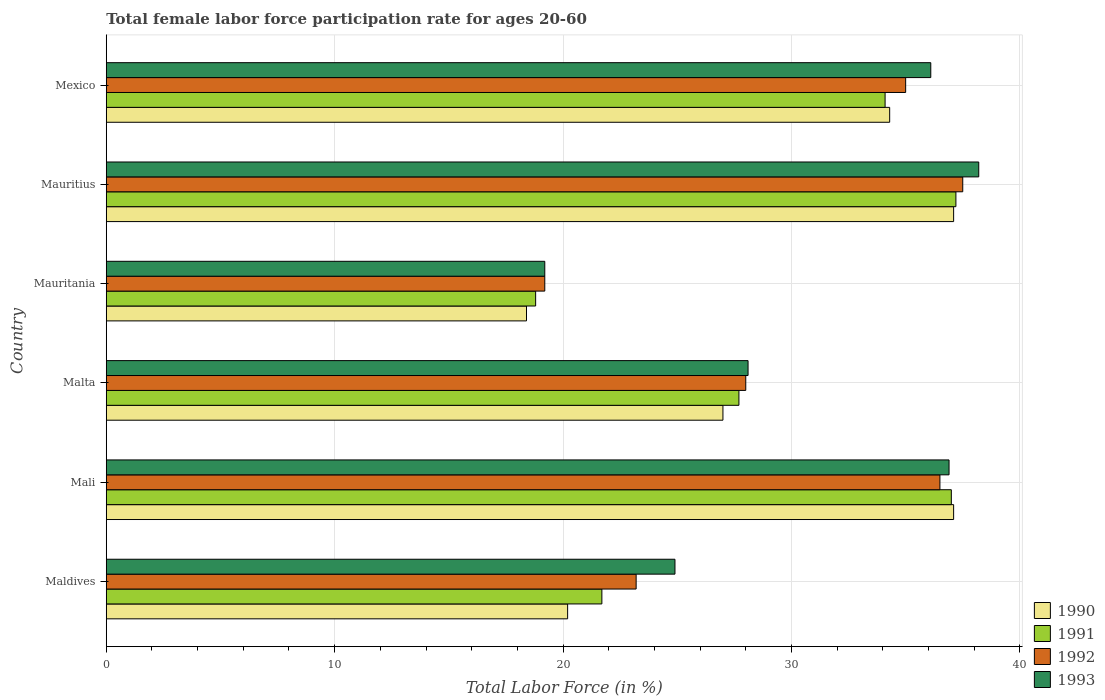How many bars are there on the 5th tick from the top?
Ensure brevity in your answer.  4. How many bars are there on the 1st tick from the bottom?
Make the answer very short. 4. What is the label of the 2nd group of bars from the top?
Provide a succinct answer. Mauritius. In how many cases, is the number of bars for a given country not equal to the number of legend labels?
Your answer should be compact. 0. What is the female labor force participation rate in 1990 in Mali?
Keep it short and to the point. 37.1. Across all countries, what is the maximum female labor force participation rate in 1991?
Ensure brevity in your answer.  37.2. Across all countries, what is the minimum female labor force participation rate in 1990?
Offer a terse response. 18.4. In which country was the female labor force participation rate in 1991 maximum?
Your answer should be very brief. Mauritius. In which country was the female labor force participation rate in 1991 minimum?
Your response must be concise. Mauritania. What is the total female labor force participation rate in 1992 in the graph?
Provide a succinct answer. 179.4. What is the difference between the female labor force participation rate in 1993 in Maldives and that in Mauritius?
Make the answer very short. -13.3. What is the difference between the female labor force participation rate in 1992 in Maldives and the female labor force participation rate in 1993 in Mauritius?
Make the answer very short. -15. What is the average female labor force participation rate in 1992 per country?
Your response must be concise. 29.9. In how many countries, is the female labor force participation rate in 1991 greater than 12 %?
Give a very brief answer. 6. What is the ratio of the female labor force participation rate in 1990 in Mali to that in Mauritania?
Your answer should be very brief. 2.02. Is the female labor force participation rate in 1992 in Maldives less than that in Malta?
Make the answer very short. Yes. Is the difference between the female labor force participation rate in 1991 in Mauritania and Mauritius greater than the difference between the female labor force participation rate in 1993 in Mauritania and Mauritius?
Give a very brief answer. Yes. What is the difference between the highest and the lowest female labor force participation rate in 1990?
Your response must be concise. 18.7. Is the sum of the female labor force participation rate in 1991 in Mauritania and Mexico greater than the maximum female labor force participation rate in 1993 across all countries?
Provide a succinct answer. Yes. Is it the case that in every country, the sum of the female labor force participation rate in 1993 and female labor force participation rate in 1991 is greater than the female labor force participation rate in 1992?
Provide a succinct answer. Yes. Are all the bars in the graph horizontal?
Keep it short and to the point. Yes. How many countries are there in the graph?
Offer a terse response. 6. What is the difference between two consecutive major ticks on the X-axis?
Provide a short and direct response. 10. How many legend labels are there?
Your answer should be compact. 4. What is the title of the graph?
Provide a short and direct response. Total female labor force participation rate for ages 20-60. What is the Total Labor Force (in %) of 1990 in Maldives?
Your answer should be compact. 20.2. What is the Total Labor Force (in %) in 1991 in Maldives?
Ensure brevity in your answer.  21.7. What is the Total Labor Force (in %) of 1992 in Maldives?
Your answer should be compact. 23.2. What is the Total Labor Force (in %) in 1993 in Maldives?
Make the answer very short. 24.9. What is the Total Labor Force (in %) in 1990 in Mali?
Your response must be concise. 37.1. What is the Total Labor Force (in %) in 1991 in Mali?
Keep it short and to the point. 37. What is the Total Labor Force (in %) of 1992 in Mali?
Provide a succinct answer. 36.5. What is the Total Labor Force (in %) of 1993 in Mali?
Your answer should be very brief. 36.9. What is the Total Labor Force (in %) in 1991 in Malta?
Make the answer very short. 27.7. What is the Total Labor Force (in %) of 1993 in Malta?
Your answer should be compact. 28.1. What is the Total Labor Force (in %) of 1990 in Mauritania?
Your answer should be compact. 18.4. What is the Total Labor Force (in %) in 1991 in Mauritania?
Ensure brevity in your answer.  18.8. What is the Total Labor Force (in %) of 1992 in Mauritania?
Your answer should be very brief. 19.2. What is the Total Labor Force (in %) in 1993 in Mauritania?
Provide a succinct answer. 19.2. What is the Total Labor Force (in %) in 1990 in Mauritius?
Keep it short and to the point. 37.1. What is the Total Labor Force (in %) of 1991 in Mauritius?
Provide a succinct answer. 37.2. What is the Total Labor Force (in %) in 1992 in Mauritius?
Your response must be concise. 37.5. What is the Total Labor Force (in %) in 1993 in Mauritius?
Keep it short and to the point. 38.2. What is the Total Labor Force (in %) of 1990 in Mexico?
Provide a succinct answer. 34.3. What is the Total Labor Force (in %) of 1991 in Mexico?
Provide a succinct answer. 34.1. What is the Total Labor Force (in %) in 1992 in Mexico?
Provide a succinct answer. 35. What is the Total Labor Force (in %) in 1993 in Mexico?
Ensure brevity in your answer.  36.1. Across all countries, what is the maximum Total Labor Force (in %) of 1990?
Make the answer very short. 37.1. Across all countries, what is the maximum Total Labor Force (in %) of 1991?
Offer a very short reply. 37.2. Across all countries, what is the maximum Total Labor Force (in %) of 1992?
Give a very brief answer. 37.5. Across all countries, what is the maximum Total Labor Force (in %) in 1993?
Ensure brevity in your answer.  38.2. Across all countries, what is the minimum Total Labor Force (in %) of 1990?
Offer a terse response. 18.4. Across all countries, what is the minimum Total Labor Force (in %) in 1991?
Give a very brief answer. 18.8. Across all countries, what is the minimum Total Labor Force (in %) of 1992?
Offer a very short reply. 19.2. Across all countries, what is the minimum Total Labor Force (in %) of 1993?
Provide a succinct answer. 19.2. What is the total Total Labor Force (in %) in 1990 in the graph?
Offer a very short reply. 174.1. What is the total Total Labor Force (in %) of 1991 in the graph?
Provide a short and direct response. 176.5. What is the total Total Labor Force (in %) in 1992 in the graph?
Your response must be concise. 179.4. What is the total Total Labor Force (in %) in 1993 in the graph?
Provide a succinct answer. 183.4. What is the difference between the Total Labor Force (in %) in 1990 in Maldives and that in Mali?
Offer a terse response. -16.9. What is the difference between the Total Labor Force (in %) of 1991 in Maldives and that in Mali?
Provide a succinct answer. -15.3. What is the difference between the Total Labor Force (in %) in 1993 in Maldives and that in Mali?
Offer a terse response. -12. What is the difference between the Total Labor Force (in %) in 1991 in Maldives and that in Malta?
Offer a very short reply. -6. What is the difference between the Total Labor Force (in %) in 1990 in Maldives and that in Mauritania?
Your response must be concise. 1.8. What is the difference between the Total Labor Force (in %) of 1993 in Maldives and that in Mauritania?
Offer a terse response. 5.7. What is the difference between the Total Labor Force (in %) of 1990 in Maldives and that in Mauritius?
Provide a succinct answer. -16.9. What is the difference between the Total Labor Force (in %) of 1991 in Maldives and that in Mauritius?
Keep it short and to the point. -15.5. What is the difference between the Total Labor Force (in %) in 1992 in Maldives and that in Mauritius?
Your answer should be compact. -14.3. What is the difference between the Total Labor Force (in %) of 1990 in Maldives and that in Mexico?
Provide a short and direct response. -14.1. What is the difference between the Total Labor Force (in %) in 1991 in Maldives and that in Mexico?
Keep it short and to the point. -12.4. What is the difference between the Total Labor Force (in %) in 1991 in Mali and that in Mauritania?
Provide a short and direct response. 18.2. What is the difference between the Total Labor Force (in %) in 1990 in Mali and that in Mauritius?
Offer a terse response. 0. What is the difference between the Total Labor Force (in %) in 1991 in Mali and that in Mauritius?
Your answer should be compact. -0.2. What is the difference between the Total Labor Force (in %) in 1992 in Mali and that in Mauritius?
Ensure brevity in your answer.  -1. What is the difference between the Total Labor Force (in %) in 1990 in Mali and that in Mexico?
Keep it short and to the point. 2.8. What is the difference between the Total Labor Force (in %) of 1992 in Mali and that in Mexico?
Offer a very short reply. 1.5. What is the difference between the Total Labor Force (in %) in 1992 in Malta and that in Mauritania?
Offer a terse response. 8.8. What is the difference between the Total Labor Force (in %) in 1993 in Malta and that in Mauritius?
Your answer should be very brief. -10.1. What is the difference between the Total Labor Force (in %) in 1990 in Malta and that in Mexico?
Offer a terse response. -7.3. What is the difference between the Total Labor Force (in %) in 1991 in Malta and that in Mexico?
Provide a succinct answer. -6.4. What is the difference between the Total Labor Force (in %) in 1993 in Malta and that in Mexico?
Keep it short and to the point. -8. What is the difference between the Total Labor Force (in %) in 1990 in Mauritania and that in Mauritius?
Offer a very short reply. -18.7. What is the difference between the Total Labor Force (in %) of 1991 in Mauritania and that in Mauritius?
Offer a terse response. -18.4. What is the difference between the Total Labor Force (in %) in 1992 in Mauritania and that in Mauritius?
Provide a short and direct response. -18.3. What is the difference between the Total Labor Force (in %) of 1993 in Mauritania and that in Mauritius?
Your response must be concise. -19. What is the difference between the Total Labor Force (in %) of 1990 in Mauritania and that in Mexico?
Your answer should be compact. -15.9. What is the difference between the Total Labor Force (in %) in 1991 in Mauritania and that in Mexico?
Your response must be concise. -15.3. What is the difference between the Total Labor Force (in %) of 1992 in Mauritania and that in Mexico?
Ensure brevity in your answer.  -15.8. What is the difference between the Total Labor Force (in %) of 1993 in Mauritania and that in Mexico?
Give a very brief answer. -16.9. What is the difference between the Total Labor Force (in %) of 1990 in Mauritius and that in Mexico?
Offer a very short reply. 2.8. What is the difference between the Total Labor Force (in %) of 1991 in Mauritius and that in Mexico?
Make the answer very short. 3.1. What is the difference between the Total Labor Force (in %) of 1992 in Mauritius and that in Mexico?
Provide a short and direct response. 2.5. What is the difference between the Total Labor Force (in %) of 1993 in Mauritius and that in Mexico?
Offer a very short reply. 2.1. What is the difference between the Total Labor Force (in %) in 1990 in Maldives and the Total Labor Force (in %) in 1991 in Mali?
Give a very brief answer. -16.8. What is the difference between the Total Labor Force (in %) of 1990 in Maldives and the Total Labor Force (in %) of 1992 in Mali?
Keep it short and to the point. -16.3. What is the difference between the Total Labor Force (in %) in 1990 in Maldives and the Total Labor Force (in %) in 1993 in Mali?
Your response must be concise. -16.7. What is the difference between the Total Labor Force (in %) in 1991 in Maldives and the Total Labor Force (in %) in 1992 in Mali?
Your answer should be very brief. -14.8. What is the difference between the Total Labor Force (in %) of 1991 in Maldives and the Total Labor Force (in %) of 1993 in Mali?
Make the answer very short. -15.2. What is the difference between the Total Labor Force (in %) in 1992 in Maldives and the Total Labor Force (in %) in 1993 in Mali?
Make the answer very short. -13.7. What is the difference between the Total Labor Force (in %) of 1990 in Maldives and the Total Labor Force (in %) of 1991 in Malta?
Offer a terse response. -7.5. What is the difference between the Total Labor Force (in %) in 1990 in Maldives and the Total Labor Force (in %) in 1993 in Malta?
Ensure brevity in your answer.  -7.9. What is the difference between the Total Labor Force (in %) in 1991 in Maldives and the Total Labor Force (in %) in 1992 in Malta?
Offer a very short reply. -6.3. What is the difference between the Total Labor Force (in %) in 1990 in Maldives and the Total Labor Force (in %) in 1992 in Mauritania?
Your answer should be compact. 1. What is the difference between the Total Labor Force (in %) of 1991 in Maldives and the Total Labor Force (in %) of 1993 in Mauritania?
Provide a succinct answer. 2.5. What is the difference between the Total Labor Force (in %) of 1992 in Maldives and the Total Labor Force (in %) of 1993 in Mauritania?
Your answer should be very brief. 4. What is the difference between the Total Labor Force (in %) in 1990 in Maldives and the Total Labor Force (in %) in 1992 in Mauritius?
Give a very brief answer. -17.3. What is the difference between the Total Labor Force (in %) of 1991 in Maldives and the Total Labor Force (in %) of 1992 in Mauritius?
Keep it short and to the point. -15.8. What is the difference between the Total Labor Force (in %) of 1991 in Maldives and the Total Labor Force (in %) of 1993 in Mauritius?
Your response must be concise. -16.5. What is the difference between the Total Labor Force (in %) in 1990 in Maldives and the Total Labor Force (in %) in 1991 in Mexico?
Give a very brief answer. -13.9. What is the difference between the Total Labor Force (in %) of 1990 in Maldives and the Total Labor Force (in %) of 1992 in Mexico?
Ensure brevity in your answer.  -14.8. What is the difference between the Total Labor Force (in %) in 1990 in Maldives and the Total Labor Force (in %) in 1993 in Mexico?
Make the answer very short. -15.9. What is the difference between the Total Labor Force (in %) of 1991 in Maldives and the Total Labor Force (in %) of 1993 in Mexico?
Ensure brevity in your answer.  -14.4. What is the difference between the Total Labor Force (in %) in 1990 in Mali and the Total Labor Force (in %) in 1991 in Malta?
Provide a short and direct response. 9.4. What is the difference between the Total Labor Force (in %) of 1990 in Mali and the Total Labor Force (in %) of 1992 in Malta?
Keep it short and to the point. 9.1. What is the difference between the Total Labor Force (in %) of 1990 in Mali and the Total Labor Force (in %) of 1993 in Malta?
Make the answer very short. 9. What is the difference between the Total Labor Force (in %) of 1990 in Mali and the Total Labor Force (in %) of 1992 in Mauritania?
Provide a succinct answer. 17.9. What is the difference between the Total Labor Force (in %) of 1991 in Mali and the Total Labor Force (in %) of 1992 in Mauritania?
Your answer should be compact. 17.8. What is the difference between the Total Labor Force (in %) in 1992 in Mali and the Total Labor Force (in %) in 1993 in Mauritania?
Give a very brief answer. 17.3. What is the difference between the Total Labor Force (in %) of 1990 in Mali and the Total Labor Force (in %) of 1991 in Mauritius?
Offer a terse response. -0.1. What is the difference between the Total Labor Force (in %) of 1990 in Mali and the Total Labor Force (in %) of 1992 in Mauritius?
Give a very brief answer. -0.4. What is the difference between the Total Labor Force (in %) in 1990 in Mali and the Total Labor Force (in %) in 1993 in Mauritius?
Your answer should be compact. -1.1. What is the difference between the Total Labor Force (in %) in 1991 in Mali and the Total Labor Force (in %) in 1992 in Mauritius?
Ensure brevity in your answer.  -0.5. What is the difference between the Total Labor Force (in %) of 1991 in Mali and the Total Labor Force (in %) of 1993 in Mauritius?
Provide a short and direct response. -1.2. What is the difference between the Total Labor Force (in %) of 1990 in Mali and the Total Labor Force (in %) of 1991 in Mexico?
Your answer should be compact. 3. What is the difference between the Total Labor Force (in %) in 1990 in Mali and the Total Labor Force (in %) in 1992 in Mexico?
Ensure brevity in your answer.  2.1. What is the difference between the Total Labor Force (in %) in 1990 in Mali and the Total Labor Force (in %) in 1993 in Mexico?
Your response must be concise. 1. What is the difference between the Total Labor Force (in %) of 1990 in Malta and the Total Labor Force (in %) of 1991 in Mauritania?
Your answer should be very brief. 8.2. What is the difference between the Total Labor Force (in %) of 1991 in Malta and the Total Labor Force (in %) of 1992 in Mauritania?
Your answer should be compact. 8.5. What is the difference between the Total Labor Force (in %) of 1991 in Malta and the Total Labor Force (in %) of 1993 in Mauritania?
Your answer should be compact. 8.5. What is the difference between the Total Labor Force (in %) of 1990 in Malta and the Total Labor Force (in %) of 1991 in Mauritius?
Give a very brief answer. -10.2. What is the difference between the Total Labor Force (in %) of 1990 in Malta and the Total Labor Force (in %) of 1992 in Mauritius?
Offer a terse response. -10.5. What is the difference between the Total Labor Force (in %) in 1990 in Malta and the Total Labor Force (in %) in 1993 in Mauritius?
Your answer should be compact. -11.2. What is the difference between the Total Labor Force (in %) of 1991 in Malta and the Total Labor Force (in %) of 1993 in Mauritius?
Make the answer very short. -10.5. What is the difference between the Total Labor Force (in %) in 1990 in Malta and the Total Labor Force (in %) in 1991 in Mexico?
Offer a very short reply. -7.1. What is the difference between the Total Labor Force (in %) of 1990 in Malta and the Total Labor Force (in %) of 1992 in Mexico?
Ensure brevity in your answer.  -8. What is the difference between the Total Labor Force (in %) in 1990 in Malta and the Total Labor Force (in %) in 1993 in Mexico?
Your answer should be compact. -9.1. What is the difference between the Total Labor Force (in %) in 1991 in Malta and the Total Labor Force (in %) in 1993 in Mexico?
Offer a terse response. -8.4. What is the difference between the Total Labor Force (in %) in 1990 in Mauritania and the Total Labor Force (in %) in 1991 in Mauritius?
Make the answer very short. -18.8. What is the difference between the Total Labor Force (in %) in 1990 in Mauritania and the Total Labor Force (in %) in 1992 in Mauritius?
Offer a very short reply. -19.1. What is the difference between the Total Labor Force (in %) of 1990 in Mauritania and the Total Labor Force (in %) of 1993 in Mauritius?
Offer a terse response. -19.8. What is the difference between the Total Labor Force (in %) of 1991 in Mauritania and the Total Labor Force (in %) of 1992 in Mauritius?
Provide a short and direct response. -18.7. What is the difference between the Total Labor Force (in %) of 1991 in Mauritania and the Total Labor Force (in %) of 1993 in Mauritius?
Ensure brevity in your answer.  -19.4. What is the difference between the Total Labor Force (in %) of 1992 in Mauritania and the Total Labor Force (in %) of 1993 in Mauritius?
Give a very brief answer. -19. What is the difference between the Total Labor Force (in %) of 1990 in Mauritania and the Total Labor Force (in %) of 1991 in Mexico?
Ensure brevity in your answer.  -15.7. What is the difference between the Total Labor Force (in %) of 1990 in Mauritania and the Total Labor Force (in %) of 1992 in Mexico?
Your response must be concise. -16.6. What is the difference between the Total Labor Force (in %) in 1990 in Mauritania and the Total Labor Force (in %) in 1993 in Mexico?
Make the answer very short. -17.7. What is the difference between the Total Labor Force (in %) of 1991 in Mauritania and the Total Labor Force (in %) of 1992 in Mexico?
Offer a terse response. -16.2. What is the difference between the Total Labor Force (in %) in 1991 in Mauritania and the Total Labor Force (in %) in 1993 in Mexico?
Ensure brevity in your answer.  -17.3. What is the difference between the Total Labor Force (in %) in 1992 in Mauritania and the Total Labor Force (in %) in 1993 in Mexico?
Offer a terse response. -16.9. What is the difference between the Total Labor Force (in %) in 1990 in Mauritius and the Total Labor Force (in %) in 1992 in Mexico?
Your response must be concise. 2.1. What is the difference between the Total Labor Force (in %) in 1990 in Mauritius and the Total Labor Force (in %) in 1993 in Mexico?
Provide a succinct answer. 1. What is the difference between the Total Labor Force (in %) in 1992 in Mauritius and the Total Labor Force (in %) in 1993 in Mexico?
Ensure brevity in your answer.  1.4. What is the average Total Labor Force (in %) of 1990 per country?
Give a very brief answer. 29.02. What is the average Total Labor Force (in %) of 1991 per country?
Your answer should be very brief. 29.42. What is the average Total Labor Force (in %) in 1992 per country?
Give a very brief answer. 29.9. What is the average Total Labor Force (in %) in 1993 per country?
Your answer should be compact. 30.57. What is the difference between the Total Labor Force (in %) of 1990 and Total Labor Force (in %) of 1991 in Maldives?
Ensure brevity in your answer.  -1.5. What is the difference between the Total Labor Force (in %) in 1991 and Total Labor Force (in %) in 1992 in Maldives?
Your answer should be compact. -1.5. What is the difference between the Total Labor Force (in %) of 1991 and Total Labor Force (in %) of 1993 in Maldives?
Provide a short and direct response. -3.2. What is the difference between the Total Labor Force (in %) of 1992 and Total Labor Force (in %) of 1993 in Maldives?
Provide a succinct answer. -1.7. What is the difference between the Total Labor Force (in %) in 1990 and Total Labor Force (in %) in 1991 in Mali?
Make the answer very short. 0.1. What is the difference between the Total Labor Force (in %) of 1990 and Total Labor Force (in %) of 1993 in Mali?
Provide a succinct answer. 0.2. What is the difference between the Total Labor Force (in %) in 1992 and Total Labor Force (in %) in 1993 in Mali?
Provide a short and direct response. -0.4. What is the difference between the Total Labor Force (in %) in 1991 and Total Labor Force (in %) in 1992 in Malta?
Keep it short and to the point. -0.3. What is the difference between the Total Labor Force (in %) of 1991 and Total Labor Force (in %) of 1993 in Malta?
Offer a terse response. -0.4. What is the difference between the Total Labor Force (in %) of 1992 and Total Labor Force (in %) of 1993 in Malta?
Give a very brief answer. -0.1. What is the difference between the Total Labor Force (in %) of 1990 and Total Labor Force (in %) of 1991 in Mauritania?
Offer a very short reply. -0.4. What is the difference between the Total Labor Force (in %) of 1990 and Total Labor Force (in %) of 1993 in Mauritania?
Offer a very short reply. -0.8. What is the difference between the Total Labor Force (in %) in 1991 and Total Labor Force (in %) in 1993 in Mauritania?
Your response must be concise. -0.4. What is the difference between the Total Labor Force (in %) in 1992 and Total Labor Force (in %) in 1993 in Mauritania?
Give a very brief answer. 0. What is the difference between the Total Labor Force (in %) of 1990 and Total Labor Force (in %) of 1993 in Mauritius?
Your response must be concise. -1.1. What is the difference between the Total Labor Force (in %) of 1991 and Total Labor Force (in %) of 1992 in Mauritius?
Make the answer very short. -0.3. What is the difference between the Total Labor Force (in %) of 1992 and Total Labor Force (in %) of 1993 in Mauritius?
Your answer should be compact. -0.7. What is the difference between the Total Labor Force (in %) of 1991 and Total Labor Force (in %) of 1993 in Mexico?
Ensure brevity in your answer.  -2. What is the ratio of the Total Labor Force (in %) in 1990 in Maldives to that in Mali?
Offer a very short reply. 0.54. What is the ratio of the Total Labor Force (in %) in 1991 in Maldives to that in Mali?
Your response must be concise. 0.59. What is the ratio of the Total Labor Force (in %) of 1992 in Maldives to that in Mali?
Your answer should be very brief. 0.64. What is the ratio of the Total Labor Force (in %) in 1993 in Maldives to that in Mali?
Ensure brevity in your answer.  0.67. What is the ratio of the Total Labor Force (in %) in 1990 in Maldives to that in Malta?
Keep it short and to the point. 0.75. What is the ratio of the Total Labor Force (in %) in 1991 in Maldives to that in Malta?
Your answer should be very brief. 0.78. What is the ratio of the Total Labor Force (in %) of 1992 in Maldives to that in Malta?
Your answer should be very brief. 0.83. What is the ratio of the Total Labor Force (in %) in 1993 in Maldives to that in Malta?
Keep it short and to the point. 0.89. What is the ratio of the Total Labor Force (in %) in 1990 in Maldives to that in Mauritania?
Give a very brief answer. 1.1. What is the ratio of the Total Labor Force (in %) of 1991 in Maldives to that in Mauritania?
Provide a succinct answer. 1.15. What is the ratio of the Total Labor Force (in %) of 1992 in Maldives to that in Mauritania?
Your answer should be compact. 1.21. What is the ratio of the Total Labor Force (in %) of 1993 in Maldives to that in Mauritania?
Give a very brief answer. 1.3. What is the ratio of the Total Labor Force (in %) in 1990 in Maldives to that in Mauritius?
Make the answer very short. 0.54. What is the ratio of the Total Labor Force (in %) in 1991 in Maldives to that in Mauritius?
Offer a very short reply. 0.58. What is the ratio of the Total Labor Force (in %) of 1992 in Maldives to that in Mauritius?
Offer a very short reply. 0.62. What is the ratio of the Total Labor Force (in %) in 1993 in Maldives to that in Mauritius?
Provide a short and direct response. 0.65. What is the ratio of the Total Labor Force (in %) in 1990 in Maldives to that in Mexico?
Your answer should be compact. 0.59. What is the ratio of the Total Labor Force (in %) in 1991 in Maldives to that in Mexico?
Provide a succinct answer. 0.64. What is the ratio of the Total Labor Force (in %) of 1992 in Maldives to that in Mexico?
Offer a terse response. 0.66. What is the ratio of the Total Labor Force (in %) of 1993 in Maldives to that in Mexico?
Ensure brevity in your answer.  0.69. What is the ratio of the Total Labor Force (in %) in 1990 in Mali to that in Malta?
Provide a short and direct response. 1.37. What is the ratio of the Total Labor Force (in %) of 1991 in Mali to that in Malta?
Offer a terse response. 1.34. What is the ratio of the Total Labor Force (in %) of 1992 in Mali to that in Malta?
Your response must be concise. 1.3. What is the ratio of the Total Labor Force (in %) of 1993 in Mali to that in Malta?
Your answer should be very brief. 1.31. What is the ratio of the Total Labor Force (in %) of 1990 in Mali to that in Mauritania?
Make the answer very short. 2.02. What is the ratio of the Total Labor Force (in %) of 1991 in Mali to that in Mauritania?
Your answer should be very brief. 1.97. What is the ratio of the Total Labor Force (in %) of 1992 in Mali to that in Mauritania?
Give a very brief answer. 1.9. What is the ratio of the Total Labor Force (in %) in 1993 in Mali to that in Mauritania?
Make the answer very short. 1.92. What is the ratio of the Total Labor Force (in %) of 1991 in Mali to that in Mauritius?
Your response must be concise. 0.99. What is the ratio of the Total Labor Force (in %) of 1992 in Mali to that in Mauritius?
Ensure brevity in your answer.  0.97. What is the ratio of the Total Labor Force (in %) in 1993 in Mali to that in Mauritius?
Ensure brevity in your answer.  0.97. What is the ratio of the Total Labor Force (in %) of 1990 in Mali to that in Mexico?
Provide a succinct answer. 1.08. What is the ratio of the Total Labor Force (in %) in 1991 in Mali to that in Mexico?
Ensure brevity in your answer.  1.08. What is the ratio of the Total Labor Force (in %) of 1992 in Mali to that in Mexico?
Offer a very short reply. 1.04. What is the ratio of the Total Labor Force (in %) in 1993 in Mali to that in Mexico?
Provide a succinct answer. 1.02. What is the ratio of the Total Labor Force (in %) of 1990 in Malta to that in Mauritania?
Your answer should be compact. 1.47. What is the ratio of the Total Labor Force (in %) of 1991 in Malta to that in Mauritania?
Give a very brief answer. 1.47. What is the ratio of the Total Labor Force (in %) in 1992 in Malta to that in Mauritania?
Give a very brief answer. 1.46. What is the ratio of the Total Labor Force (in %) of 1993 in Malta to that in Mauritania?
Ensure brevity in your answer.  1.46. What is the ratio of the Total Labor Force (in %) of 1990 in Malta to that in Mauritius?
Make the answer very short. 0.73. What is the ratio of the Total Labor Force (in %) in 1991 in Malta to that in Mauritius?
Give a very brief answer. 0.74. What is the ratio of the Total Labor Force (in %) of 1992 in Malta to that in Mauritius?
Keep it short and to the point. 0.75. What is the ratio of the Total Labor Force (in %) of 1993 in Malta to that in Mauritius?
Provide a short and direct response. 0.74. What is the ratio of the Total Labor Force (in %) in 1990 in Malta to that in Mexico?
Keep it short and to the point. 0.79. What is the ratio of the Total Labor Force (in %) of 1991 in Malta to that in Mexico?
Offer a very short reply. 0.81. What is the ratio of the Total Labor Force (in %) of 1993 in Malta to that in Mexico?
Offer a terse response. 0.78. What is the ratio of the Total Labor Force (in %) in 1990 in Mauritania to that in Mauritius?
Provide a short and direct response. 0.5. What is the ratio of the Total Labor Force (in %) of 1991 in Mauritania to that in Mauritius?
Give a very brief answer. 0.51. What is the ratio of the Total Labor Force (in %) in 1992 in Mauritania to that in Mauritius?
Ensure brevity in your answer.  0.51. What is the ratio of the Total Labor Force (in %) in 1993 in Mauritania to that in Mauritius?
Offer a very short reply. 0.5. What is the ratio of the Total Labor Force (in %) of 1990 in Mauritania to that in Mexico?
Keep it short and to the point. 0.54. What is the ratio of the Total Labor Force (in %) of 1991 in Mauritania to that in Mexico?
Provide a succinct answer. 0.55. What is the ratio of the Total Labor Force (in %) of 1992 in Mauritania to that in Mexico?
Make the answer very short. 0.55. What is the ratio of the Total Labor Force (in %) in 1993 in Mauritania to that in Mexico?
Your response must be concise. 0.53. What is the ratio of the Total Labor Force (in %) of 1990 in Mauritius to that in Mexico?
Make the answer very short. 1.08. What is the ratio of the Total Labor Force (in %) of 1991 in Mauritius to that in Mexico?
Your answer should be compact. 1.09. What is the ratio of the Total Labor Force (in %) of 1992 in Mauritius to that in Mexico?
Your answer should be compact. 1.07. What is the ratio of the Total Labor Force (in %) of 1993 in Mauritius to that in Mexico?
Provide a succinct answer. 1.06. What is the difference between the highest and the second highest Total Labor Force (in %) of 1991?
Provide a succinct answer. 0.2. What is the difference between the highest and the lowest Total Labor Force (in %) in 1990?
Your response must be concise. 18.7. What is the difference between the highest and the lowest Total Labor Force (in %) in 1991?
Provide a short and direct response. 18.4. What is the difference between the highest and the lowest Total Labor Force (in %) of 1993?
Make the answer very short. 19. 